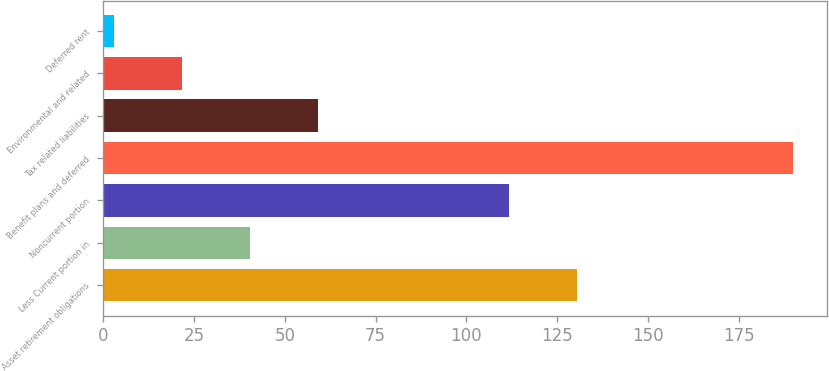Convert chart to OTSL. <chart><loc_0><loc_0><loc_500><loc_500><bar_chart><fcel>Asset retirement obligations<fcel>Less Current portion in<fcel>Noncurrent portion<fcel>Benefit plans and deferred<fcel>Tax related liabilities<fcel>Environmental and related<fcel>Deferred rent<nl><fcel>130.4<fcel>40.3<fcel>111.7<fcel>189.9<fcel>59<fcel>21.6<fcel>2.9<nl></chart> 